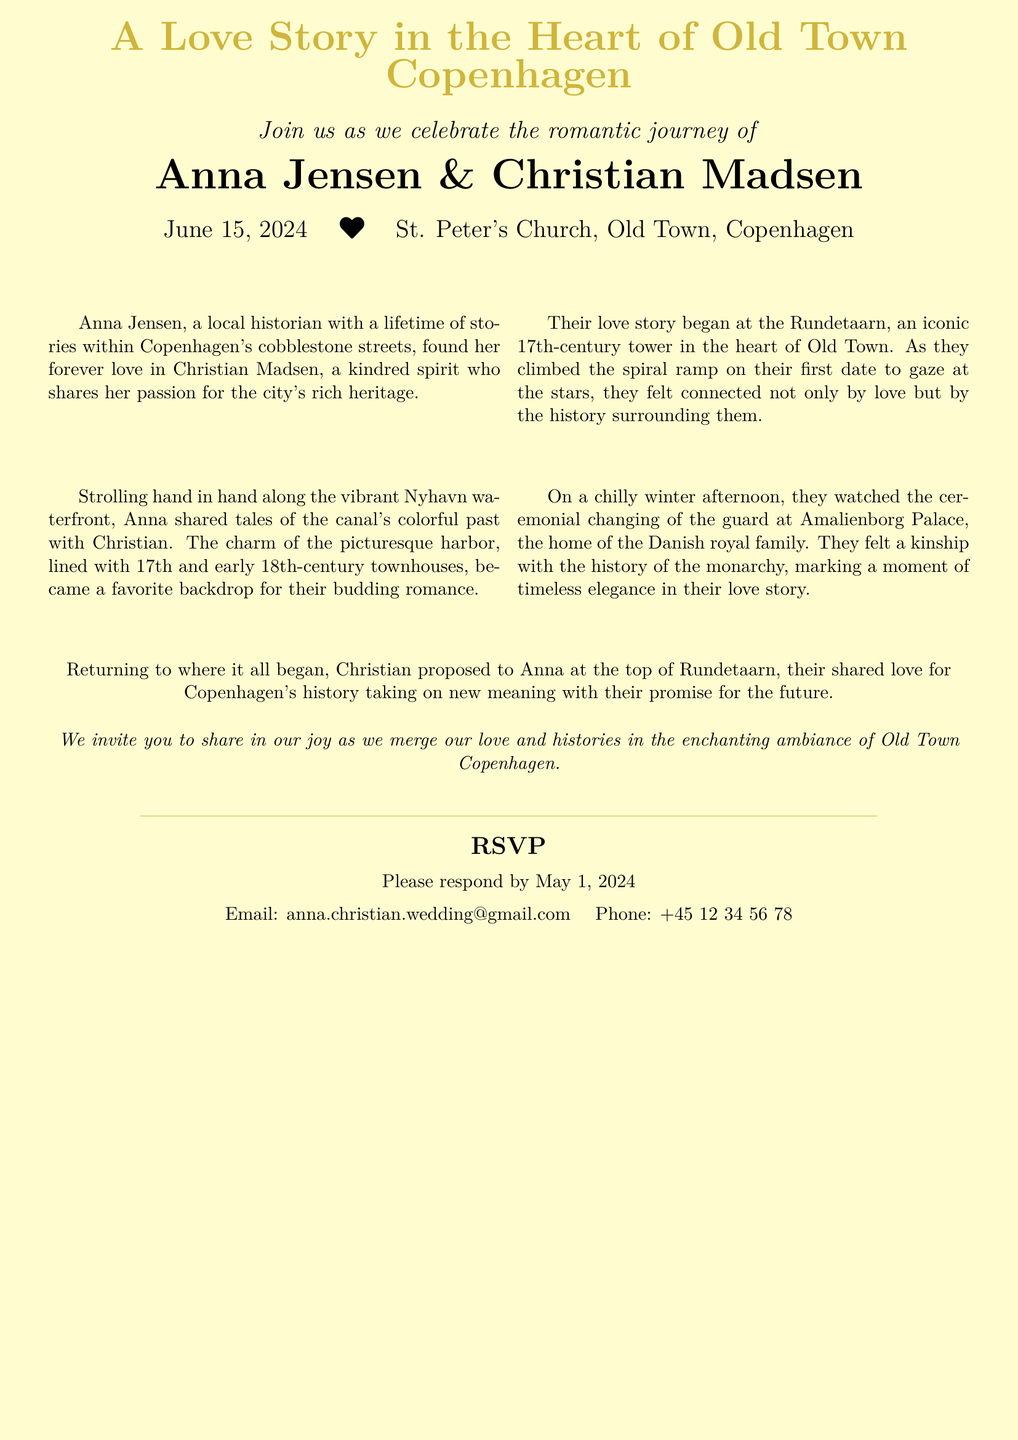What date is the wedding? The wedding date is explicitly stated in the invitation as June 15, 2024.
Answer: June 15, 2024 Who are the couple getting married? The invitation provides the names of the couple as Anna Jensen and Christian Madsen.
Answer: Anna Jensen & Christian Madsen Where will the wedding ceremony take place? The location of the wedding ceremony is mentioned in the document as St. Peter's Church, Old Town, Copenhagen.
Answer: St. Peter's Church, Old Town, Copenhagen What is Anna's profession? The document describes Anna as a local historian, indicating her professional background.
Answer: local historian What historical site is significant to the couple’s love story? The Rundetaarn is highlighted in their love story, emphasizing its importance.
Answer: Rundetaarn What is the RSVP deadline? The invitation specifies the deadline for responding as May 1, 2024.
Answer: May 1, 2024 What type of illustrations accompany the invitation? The document suggests that there are vintage-style illustrations that complement the narrative but does not specify them.
Answer: vintage-style illustrations What historical relationship do Anna and Christian share? The couple is said to share a passion for the city’s rich heritage, indicating a mutual interest in history.
Answer: shared passion for history 